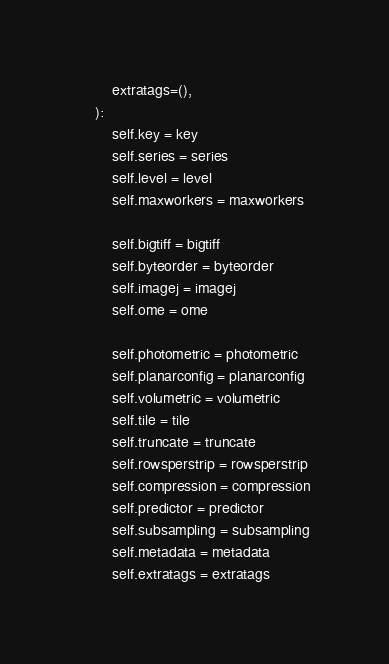<code> <loc_0><loc_0><loc_500><loc_500><_Python_>        extratags=(),
    ):
        self.key = key
        self.series = series
        self.level = level
        self.maxworkers = maxworkers

        self.bigtiff = bigtiff
        self.byteorder = byteorder
        self.imagej = imagej
        self.ome = ome

        self.photometric = photometric
        self.planarconfig = planarconfig
        self.volumetric = volumetric
        self.tile = tile
        self.truncate = truncate
        self.rowsperstrip = rowsperstrip
        self.compression = compression
        self.predictor = predictor
        self.subsampling = subsampling
        self.metadata = metadata
        self.extratags = extratags
</code> 